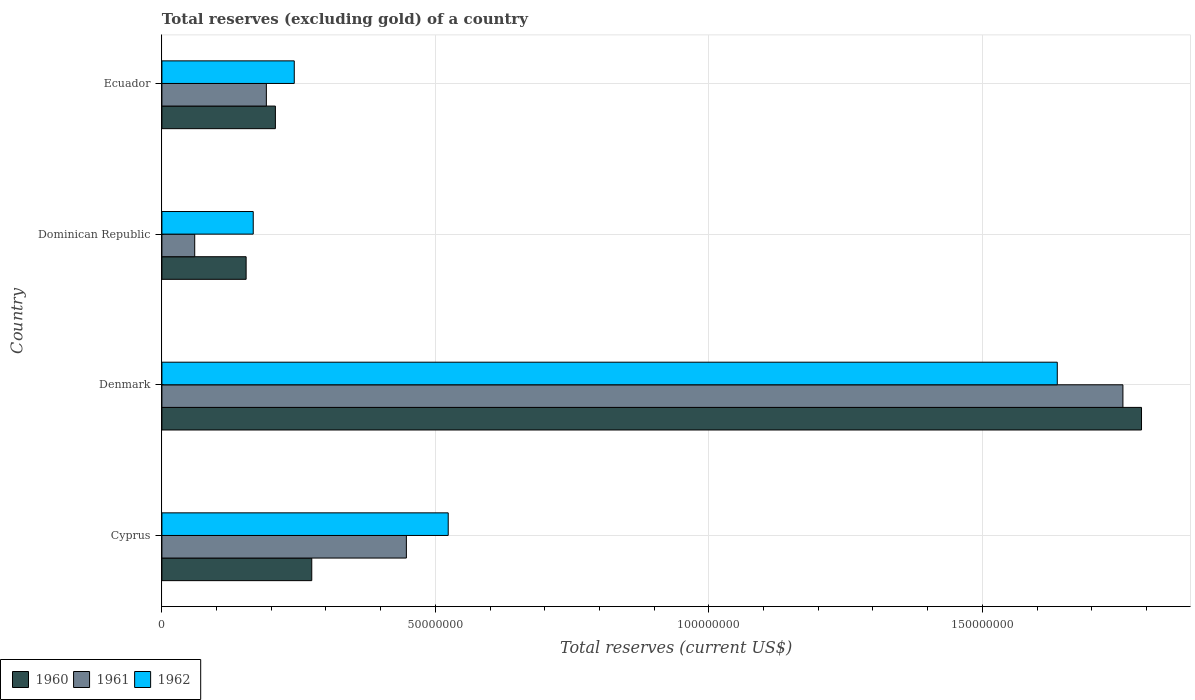How many different coloured bars are there?
Give a very brief answer. 3. Are the number of bars on each tick of the Y-axis equal?
Your answer should be compact. Yes. How many bars are there on the 1st tick from the bottom?
Ensure brevity in your answer.  3. What is the label of the 1st group of bars from the top?
Your response must be concise. Ecuador. What is the total reserves (excluding gold) in 1962 in Dominican Republic?
Your response must be concise. 1.67e+07. Across all countries, what is the maximum total reserves (excluding gold) in 1961?
Your response must be concise. 1.76e+08. Across all countries, what is the minimum total reserves (excluding gold) in 1960?
Your response must be concise. 1.54e+07. In which country was the total reserves (excluding gold) in 1960 maximum?
Provide a succinct answer. Denmark. In which country was the total reserves (excluding gold) in 1962 minimum?
Ensure brevity in your answer.  Dominican Republic. What is the total total reserves (excluding gold) in 1960 in the graph?
Make the answer very short. 2.43e+08. What is the difference between the total reserves (excluding gold) in 1960 in Denmark and the total reserves (excluding gold) in 1962 in Dominican Republic?
Provide a succinct answer. 1.62e+08. What is the average total reserves (excluding gold) in 1960 per country?
Your answer should be very brief. 6.07e+07. What is the difference between the total reserves (excluding gold) in 1962 and total reserves (excluding gold) in 1961 in Denmark?
Offer a terse response. -1.20e+07. In how many countries, is the total reserves (excluding gold) in 1962 greater than 20000000 US$?
Provide a short and direct response. 3. What is the ratio of the total reserves (excluding gold) in 1962 in Cyprus to that in Dominican Republic?
Provide a succinct answer. 3.13. Is the total reserves (excluding gold) in 1961 in Denmark less than that in Ecuador?
Your answer should be very brief. No. Is the difference between the total reserves (excluding gold) in 1962 in Cyprus and Denmark greater than the difference between the total reserves (excluding gold) in 1961 in Cyprus and Denmark?
Provide a succinct answer. Yes. What is the difference between the highest and the second highest total reserves (excluding gold) in 1962?
Keep it short and to the point. 1.11e+08. What is the difference between the highest and the lowest total reserves (excluding gold) in 1960?
Your response must be concise. 1.64e+08. Is the sum of the total reserves (excluding gold) in 1960 in Dominican Republic and Ecuador greater than the maximum total reserves (excluding gold) in 1961 across all countries?
Your answer should be very brief. No. What does the 3rd bar from the top in Dominican Republic represents?
Provide a succinct answer. 1960. What is the difference between two consecutive major ticks on the X-axis?
Your response must be concise. 5.00e+07. Are the values on the major ticks of X-axis written in scientific E-notation?
Give a very brief answer. No. Does the graph contain grids?
Offer a terse response. Yes. Where does the legend appear in the graph?
Ensure brevity in your answer.  Bottom left. How many legend labels are there?
Ensure brevity in your answer.  3. What is the title of the graph?
Provide a succinct answer. Total reserves (excluding gold) of a country. What is the label or title of the X-axis?
Make the answer very short. Total reserves (current US$). What is the label or title of the Y-axis?
Give a very brief answer. Country. What is the Total reserves (current US$) of 1960 in Cyprus?
Keep it short and to the point. 2.74e+07. What is the Total reserves (current US$) of 1961 in Cyprus?
Offer a terse response. 4.47e+07. What is the Total reserves (current US$) of 1962 in Cyprus?
Give a very brief answer. 5.23e+07. What is the Total reserves (current US$) of 1960 in Denmark?
Your answer should be very brief. 1.79e+08. What is the Total reserves (current US$) of 1961 in Denmark?
Offer a very short reply. 1.76e+08. What is the Total reserves (current US$) of 1962 in Denmark?
Provide a succinct answer. 1.64e+08. What is the Total reserves (current US$) of 1960 in Dominican Republic?
Offer a terse response. 1.54e+07. What is the Total reserves (current US$) in 1962 in Dominican Republic?
Provide a succinct answer. 1.67e+07. What is the Total reserves (current US$) of 1960 in Ecuador?
Make the answer very short. 2.07e+07. What is the Total reserves (current US$) in 1961 in Ecuador?
Provide a short and direct response. 1.91e+07. What is the Total reserves (current US$) in 1962 in Ecuador?
Keep it short and to the point. 2.42e+07. Across all countries, what is the maximum Total reserves (current US$) in 1960?
Your answer should be very brief. 1.79e+08. Across all countries, what is the maximum Total reserves (current US$) in 1961?
Ensure brevity in your answer.  1.76e+08. Across all countries, what is the maximum Total reserves (current US$) of 1962?
Ensure brevity in your answer.  1.64e+08. Across all countries, what is the minimum Total reserves (current US$) in 1960?
Your answer should be compact. 1.54e+07. Across all countries, what is the minimum Total reserves (current US$) in 1962?
Offer a terse response. 1.67e+07. What is the total Total reserves (current US$) of 1960 in the graph?
Make the answer very short. 2.43e+08. What is the total Total reserves (current US$) in 1961 in the graph?
Make the answer very short. 2.46e+08. What is the total Total reserves (current US$) in 1962 in the graph?
Keep it short and to the point. 2.57e+08. What is the difference between the Total reserves (current US$) of 1960 in Cyprus and that in Denmark?
Offer a terse response. -1.52e+08. What is the difference between the Total reserves (current US$) of 1961 in Cyprus and that in Denmark?
Your answer should be compact. -1.31e+08. What is the difference between the Total reserves (current US$) in 1962 in Cyprus and that in Denmark?
Offer a terse response. -1.11e+08. What is the difference between the Total reserves (current US$) of 1961 in Cyprus and that in Dominican Republic?
Give a very brief answer. 3.87e+07. What is the difference between the Total reserves (current US$) of 1962 in Cyprus and that in Dominican Republic?
Your answer should be very brief. 3.56e+07. What is the difference between the Total reserves (current US$) in 1960 in Cyprus and that in Ecuador?
Ensure brevity in your answer.  6.65e+06. What is the difference between the Total reserves (current US$) of 1961 in Cyprus and that in Ecuador?
Offer a terse response. 2.56e+07. What is the difference between the Total reserves (current US$) in 1962 in Cyprus and that in Ecuador?
Ensure brevity in your answer.  2.81e+07. What is the difference between the Total reserves (current US$) in 1960 in Denmark and that in Dominican Republic?
Offer a terse response. 1.64e+08. What is the difference between the Total reserves (current US$) in 1961 in Denmark and that in Dominican Republic?
Ensure brevity in your answer.  1.70e+08. What is the difference between the Total reserves (current US$) in 1962 in Denmark and that in Dominican Republic?
Provide a succinct answer. 1.47e+08. What is the difference between the Total reserves (current US$) in 1960 in Denmark and that in Ecuador?
Provide a short and direct response. 1.58e+08. What is the difference between the Total reserves (current US$) in 1961 in Denmark and that in Ecuador?
Keep it short and to the point. 1.57e+08. What is the difference between the Total reserves (current US$) in 1962 in Denmark and that in Ecuador?
Offer a very short reply. 1.40e+08. What is the difference between the Total reserves (current US$) in 1960 in Dominican Republic and that in Ecuador?
Provide a short and direct response. -5.35e+06. What is the difference between the Total reserves (current US$) of 1961 in Dominican Republic and that in Ecuador?
Provide a short and direct response. -1.31e+07. What is the difference between the Total reserves (current US$) of 1962 in Dominican Republic and that in Ecuador?
Keep it short and to the point. -7.50e+06. What is the difference between the Total reserves (current US$) of 1960 in Cyprus and the Total reserves (current US$) of 1961 in Denmark?
Provide a succinct answer. -1.48e+08. What is the difference between the Total reserves (current US$) of 1960 in Cyprus and the Total reserves (current US$) of 1962 in Denmark?
Keep it short and to the point. -1.36e+08. What is the difference between the Total reserves (current US$) of 1961 in Cyprus and the Total reserves (current US$) of 1962 in Denmark?
Offer a very short reply. -1.19e+08. What is the difference between the Total reserves (current US$) of 1960 in Cyprus and the Total reserves (current US$) of 1961 in Dominican Republic?
Make the answer very short. 2.14e+07. What is the difference between the Total reserves (current US$) of 1960 in Cyprus and the Total reserves (current US$) of 1962 in Dominican Republic?
Your answer should be compact. 1.07e+07. What is the difference between the Total reserves (current US$) of 1961 in Cyprus and the Total reserves (current US$) of 1962 in Dominican Republic?
Provide a short and direct response. 2.80e+07. What is the difference between the Total reserves (current US$) in 1960 in Cyprus and the Total reserves (current US$) in 1961 in Ecuador?
Your response must be concise. 8.30e+06. What is the difference between the Total reserves (current US$) in 1960 in Cyprus and the Total reserves (current US$) in 1962 in Ecuador?
Offer a very short reply. 3.20e+06. What is the difference between the Total reserves (current US$) of 1961 in Cyprus and the Total reserves (current US$) of 1962 in Ecuador?
Keep it short and to the point. 2.05e+07. What is the difference between the Total reserves (current US$) in 1960 in Denmark and the Total reserves (current US$) in 1961 in Dominican Republic?
Keep it short and to the point. 1.73e+08. What is the difference between the Total reserves (current US$) of 1960 in Denmark and the Total reserves (current US$) of 1962 in Dominican Republic?
Give a very brief answer. 1.62e+08. What is the difference between the Total reserves (current US$) of 1961 in Denmark and the Total reserves (current US$) of 1962 in Dominican Republic?
Keep it short and to the point. 1.59e+08. What is the difference between the Total reserves (current US$) of 1960 in Denmark and the Total reserves (current US$) of 1961 in Ecuador?
Keep it short and to the point. 1.60e+08. What is the difference between the Total reserves (current US$) of 1960 in Denmark and the Total reserves (current US$) of 1962 in Ecuador?
Give a very brief answer. 1.55e+08. What is the difference between the Total reserves (current US$) of 1961 in Denmark and the Total reserves (current US$) of 1962 in Ecuador?
Make the answer very short. 1.52e+08. What is the difference between the Total reserves (current US$) in 1960 in Dominican Republic and the Total reserves (current US$) in 1961 in Ecuador?
Your answer should be compact. -3.70e+06. What is the difference between the Total reserves (current US$) in 1960 in Dominican Republic and the Total reserves (current US$) in 1962 in Ecuador?
Provide a short and direct response. -8.80e+06. What is the difference between the Total reserves (current US$) in 1961 in Dominican Republic and the Total reserves (current US$) in 1962 in Ecuador?
Offer a very short reply. -1.82e+07. What is the average Total reserves (current US$) of 1960 per country?
Your answer should be very brief. 6.07e+07. What is the average Total reserves (current US$) in 1961 per country?
Provide a short and direct response. 6.14e+07. What is the average Total reserves (current US$) of 1962 per country?
Your answer should be very brief. 6.42e+07. What is the difference between the Total reserves (current US$) of 1960 and Total reserves (current US$) of 1961 in Cyprus?
Provide a succinct answer. -1.73e+07. What is the difference between the Total reserves (current US$) in 1960 and Total reserves (current US$) in 1962 in Cyprus?
Give a very brief answer. -2.49e+07. What is the difference between the Total reserves (current US$) of 1961 and Total reserves (current US$) of 1962 in Cyprus?
Your response must be concise. -7.65e+06. What is the difference between the Total reserves (current US$) of 1960 and Total reserves (current US$) of 1961 in Denmark?
Make the answer very short. 3.40e+06. What is the difference between the Total reserves (current US$) in 1960 and Total reserves (current US$) in 1962 in Denmark?
Your response must be concise. 1.54e+07. What is the difference between the Total reserves (current US$) of 1961 and Total reserves (current US$) of 1962 in Denmark?
Make the answer very short. 1.20e+07. What is the difference between the Total reserves (current US$) in 1960 and Total reserves (current US$) in 1961 in Dominican Republic?
Offer a terse response. 9.40e+06. What is the difference between the Total reserves (current US$) in 1960 and Total reserves (current US$) in 1962 in Dominican Republic?
Provide a short and direct response. -1.30e+06. What is the difference between the Total reserves (current US$) of 1961 and Total reserves (current US$) of 1962 in Dominican Republic?
Provide a short and direct response. -1.07e+07. What is the difference between the Total reserves (current US$) of 1960 and Total reserves (current US$) of 1961 in Ecuador?
Make the answer very short. 1.65e+06. What is the difference between the Total reserves (current US$) in 1960 and Total reserves (current US$) in 1962 in Ecuador?
Give a very brief answer. -3.45e+06. What is the difference between the Total reserves (current US$) of 1961 and Total reserves (current US$) of 1962 in Ecuador?
Your response must be concise. -5.10e+06. What is the ratio of the Total reserves (current US$) of 1960 in Cyprus to that in Denmark?
Your answer should be compact. 0.15. What is the ratio of the Total reserves (current US$) in 1961 in Cyprus to that in Denmark?
Your answer should be compact. 0.25. What is the ratio of the Total reserves (current US$) in 1962 in Cyprus to that in Denmark?
Your response must be concise. 0.32. What is the ratio of the Total reserves (current US$) of 1960 in Cyprus to that in Dominican Republic?
Ensure brevity in your answer.  1.78. What is the ratio of the Total reserves (current US$) in 1961 in Cyprus to that in Dominican Republic?
Your response must be concise. 7.45. What is the ratio of the Total reserves (current US$) in 1962 in Cyprus to that in Dominican Republic?
Keep it short and to the point. 3.13. What is the ratio of the Total reserves (current US$) in 1960 in Cyprus to that in Ecuador?
Make the answer very short. 1.32. What is the ratio of the Total reserves (current US$) in 1961 in Cyprus to that in Ecuador?
Provide a short and direct response. 2.34. What is the ratio of the Total reserves (current US$) of 1962 in Cyprus to that in Ecuador?
Your response must be concise. 2.16. What is the ratio of the Total reserves (current US$) of 1960 in Denmark to that in Dominican Republic?
Provide a short and direct response. 11.63. What is the ratio of the Total reserves (current US$) of 1961 in Denmark to that in Dominican Republic?
Offer a very short reply. 29.29. What is the ratio of the Total reserves (current US$) in 1962 in Denmark to that in Dominican Republic?
Ensure brevity in your answer.  9.8. What is the ratio of the Total reserves (current US$) in 1960 in Denmark to that in Ecuador?
Provide a succinct answer. 8.63. What is the ratio of the Total reserves (current US$) in 1961 in Denmark to that in Ecuador?
Make the answer very short. 9.2. What is the ratio of the Total reserves (current US$) in 1962 in Denmark to that in Ecuador?
Your answer should be very brief. 6.76. What is the ratio of the Total reserves (current US$) in 1960 in Dominican Republic to that in Ecuador?
Offer a terse response. 0.74. What is the ratio of the Total reserves (current US$) of 1961 in Dominican Republic to that in Ecuador?
Your answer should be very brief. 0.31. What is the ratio of the Total reserves (current US$) of 1962 in Dominican Republic to that in Ecuador?
Provide a succinct answer. 0.69. What is the difference between the highest and the second highest Total reserves (current US$) in 1960?
Ensure brevity in your answer.  1.52e+08. What is the difference between the highest and the second highest Total reserves (current US$) in 1961?
Make the answer very short. 1.31e+08. What is the difference between the highest and the second highest Total reserves (current US$) of 1962?
Your answer should be very brief. 1.11e+08. What is the difference between the highest and the lowest Total reserves (current US$) in 1960?
Your answer should be very brief. 1.64e+08. What is the difference between the highest and the lowest Total reserves (current US$) in 1961?
Your response must be concise. 1.70e+08. What is the difference between the highest and the lowest Total reserves (current US$) of 1962?
Ensure brevity in your answer.  1.47e+08. 